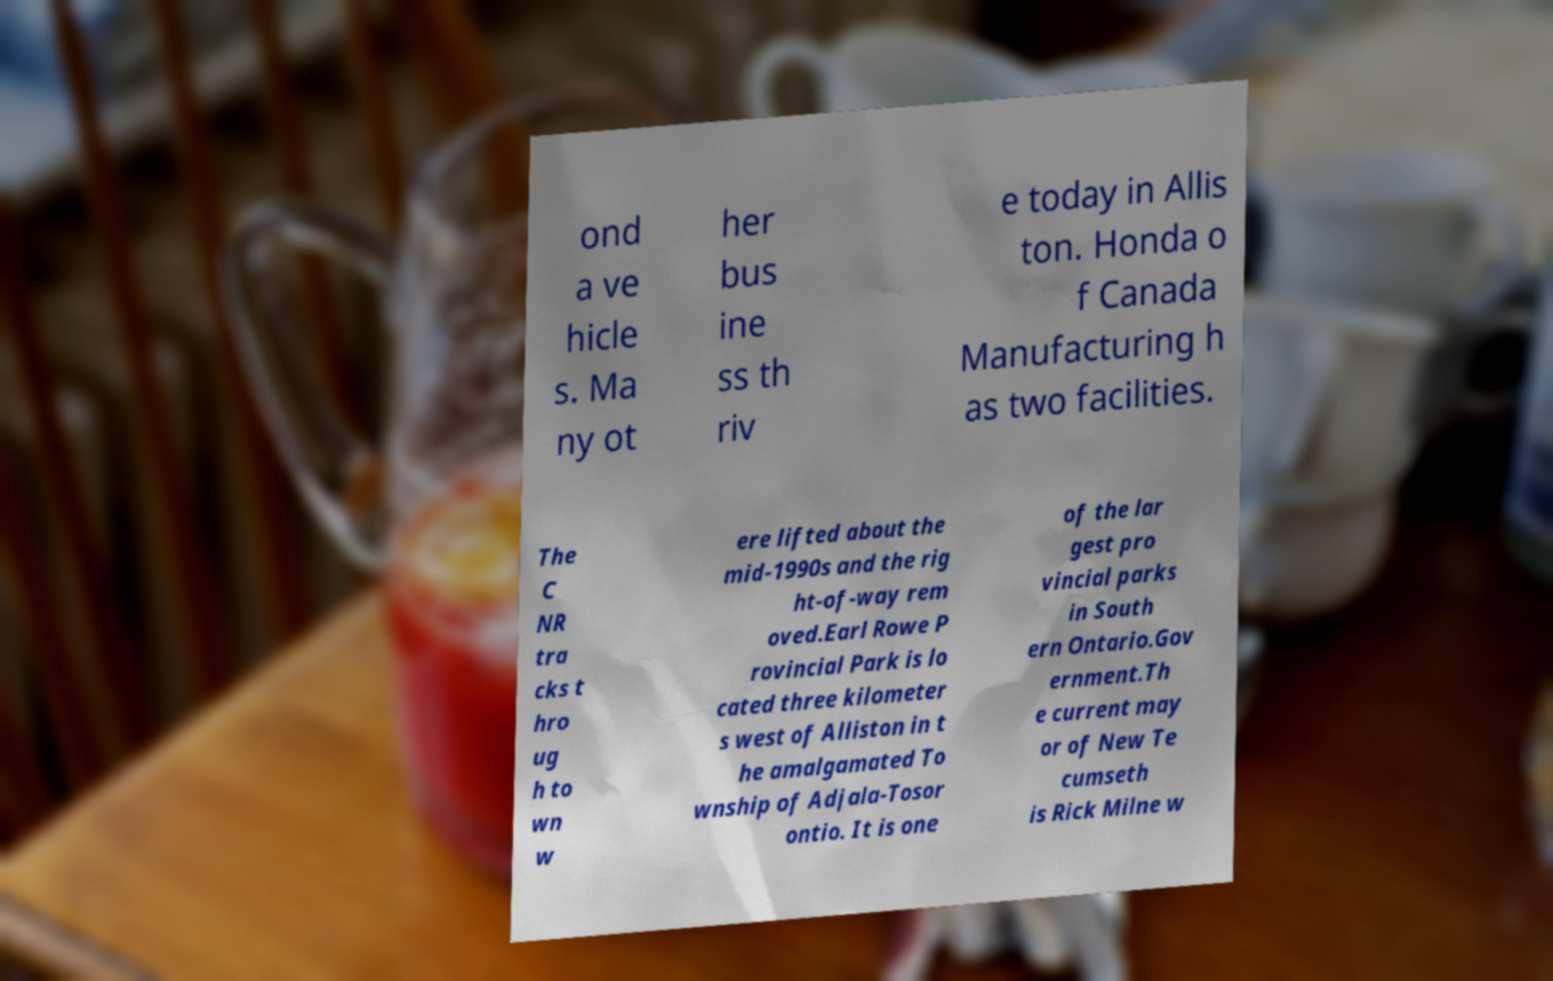Please identify and transcribe the text found in this image. ond a ve hicle s. Ma ny ot her bus ine ss th riv e today in Allis ton. Honda o f Canada Manufacturing h as two facilities. The C NR tra cks t hro ug h to wn w ere lifted about the mid-1990s and the rig ht-of-way rem oved.Earl Rowe P rovincial Park is lo cated three kilometer s west of Alliston in t he amalgamated To wnship of Adjala-Tosor ontio. It is one of the lar gest pro vincial parks in South ern Ontario.Gov ernment.Th e current may or of New Te cumseth is Rick Milne w 